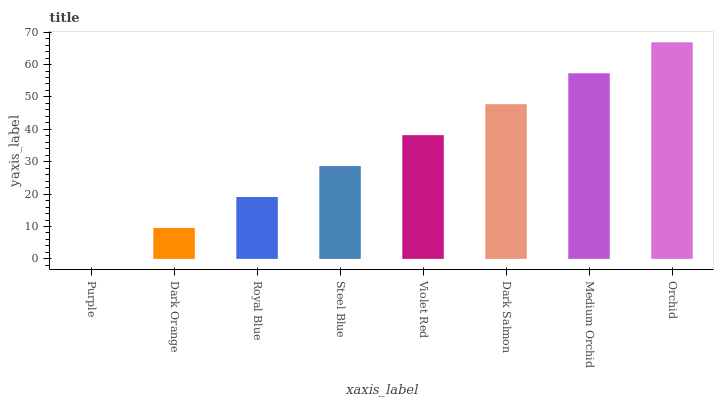Is Dark Orange the minimum?
Answer yes or no. No. Is Dark Orange the maximum?
Answer yes or no. No. Is Dark Orange greater than Purple?
Answer yes or no. Yes. Is Purple less than Dark Orange?
Answer yes or no. Yes. Is Purple greater than Dark Orange?
Answer yes or no. No. Is Dark Orange less than Purple?
Answer yes or no. No. Is Violet Red the high median?
Answer yes or no. Yes. Is Steel Blue the low median?
Answer yes or no. Yes. Is Royal Blue the high median?
Answer yes or no. No. Is Royal Blue the low median?
Answer yes or no. No. 